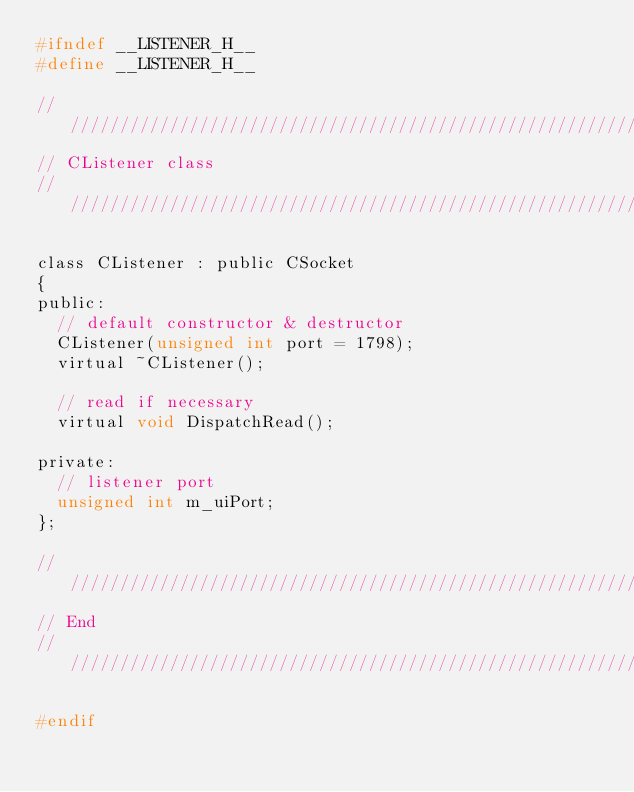Convert code to text. <code><loc_0><loc_0><loc_500><loc_500><_C_>#ifndef __LISTENER_H__
#define __LISTENER_H__

//////////////////////////////////////////////////////////////////////////
// CListener class
//////////////////////////////////////////////////////////////////////////

class CListener : public CSocket
{
public:
	// default constructor & destructor
	CListener(unsigned int port = 1798);
	virtual ~CListener();

	// read if necessary
	virtual void DispatchRead();

private:
	// listener port
	unsigned int m_uiPort;
};

//////////////////////////////////////////////////////////////////////////
// End
//////////////////////////////////////////////////////////////////////////

#endif
</code> 